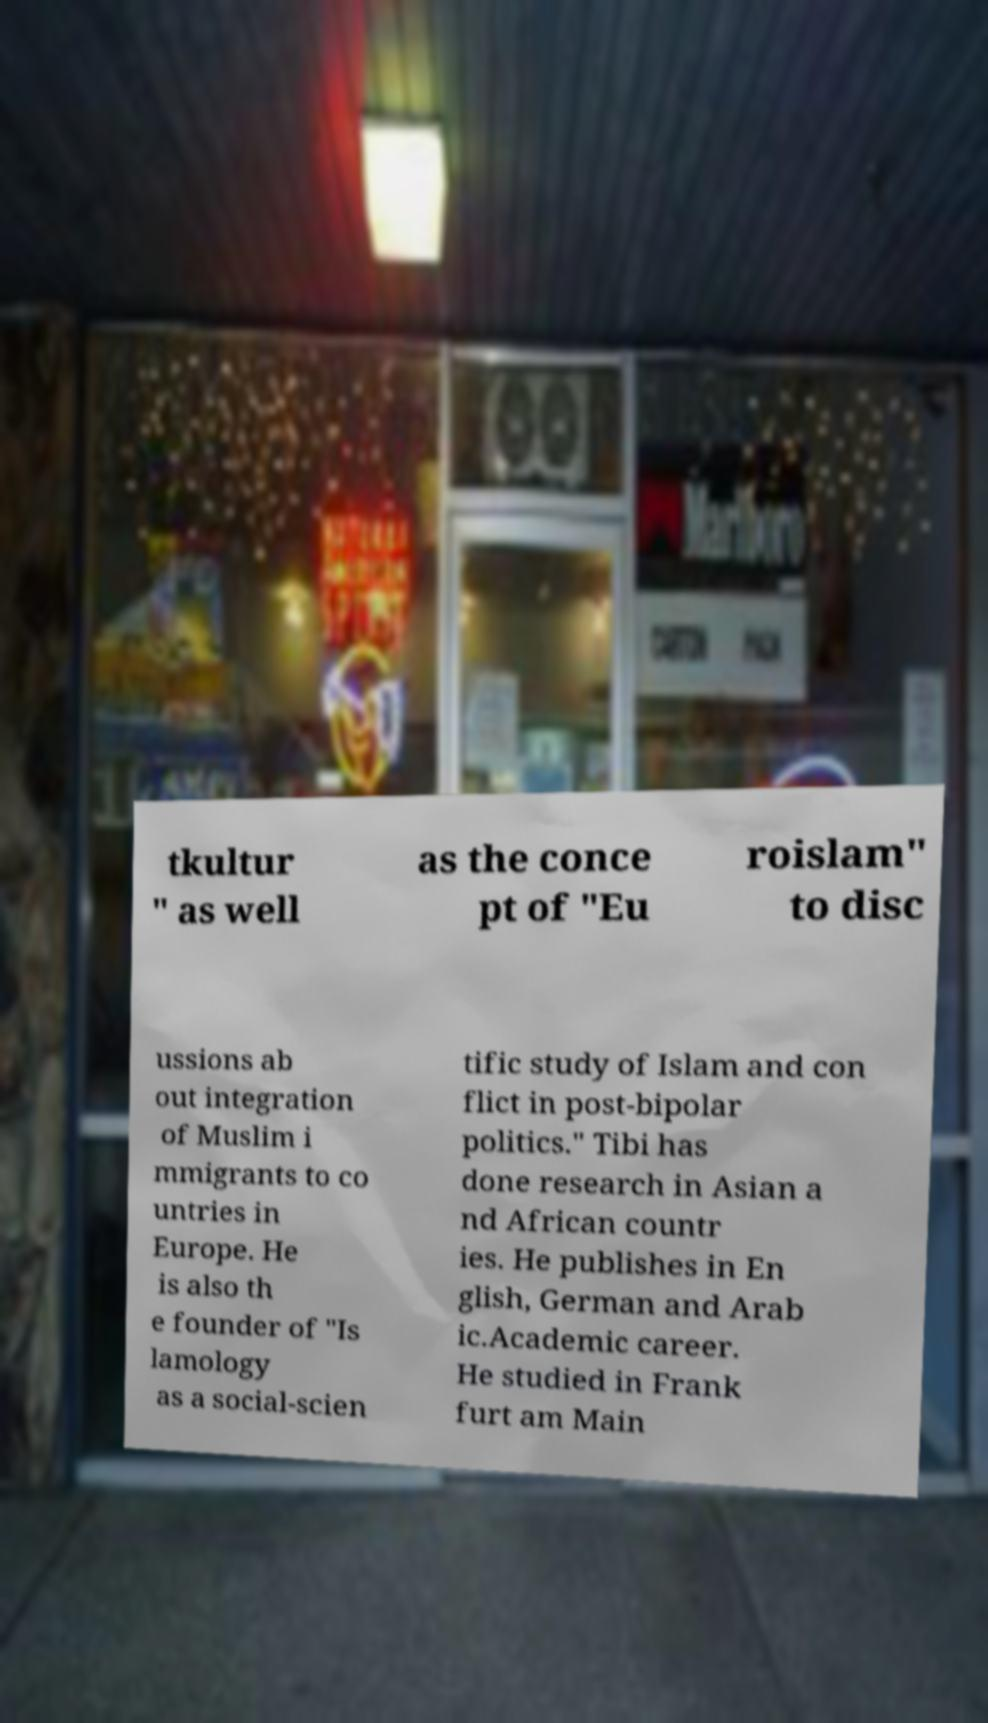For documentation purposes, I need the text within this image transcribed. Could you provide that? tkultur " as well as the conce pt of "Eu roislam" to disc ussions ab out integration of Muslim i mmigrants to co untries in Europe. He is also th e founder of "Is lamology as a social-scien tific study of Islam and con flict in post-bipolar politics." Tibi has done research in Asian a nd African countr ies. He publishes in En glish, German and Arab ic.Academic career. He studied in Frank furt am Main 